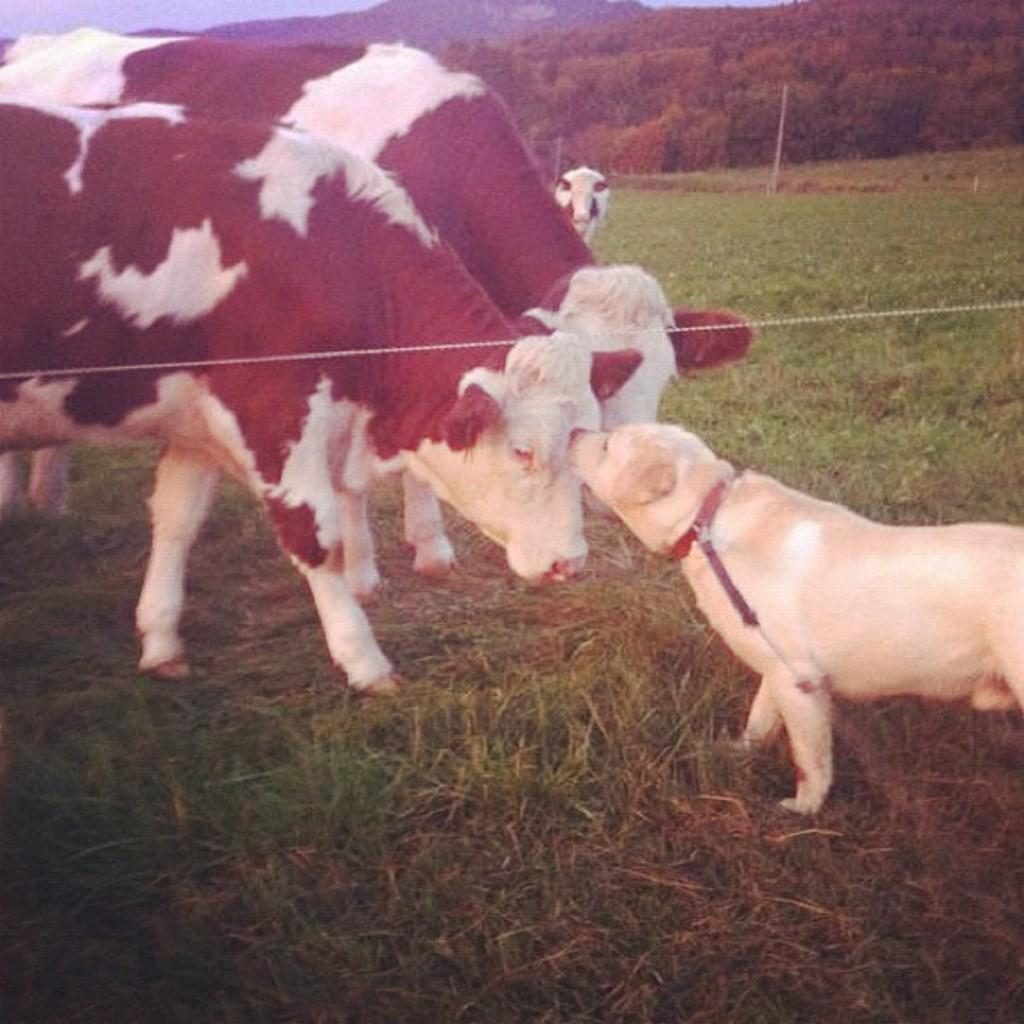What types of living organisms are present in the image? There are animals in the image. What colors can be observed on the animals? The animals have cream, white, and black colors. What can be seen in the background of the image? There are plants and trees in the background of the image. What color are the plants and trees? The plants and trees have a green color. What else is visible in the image? The sky is visible in the image. What color is the sky? The sky has a blue color. What type of machine is being used by the army in the image? There is no machine or army present in the image; it features animals, plants, trees, and the sky. What is the argument about in the image? There is no argument or discussion taking place in the image; it is a scene with animals, plants, trees, and the sky. 